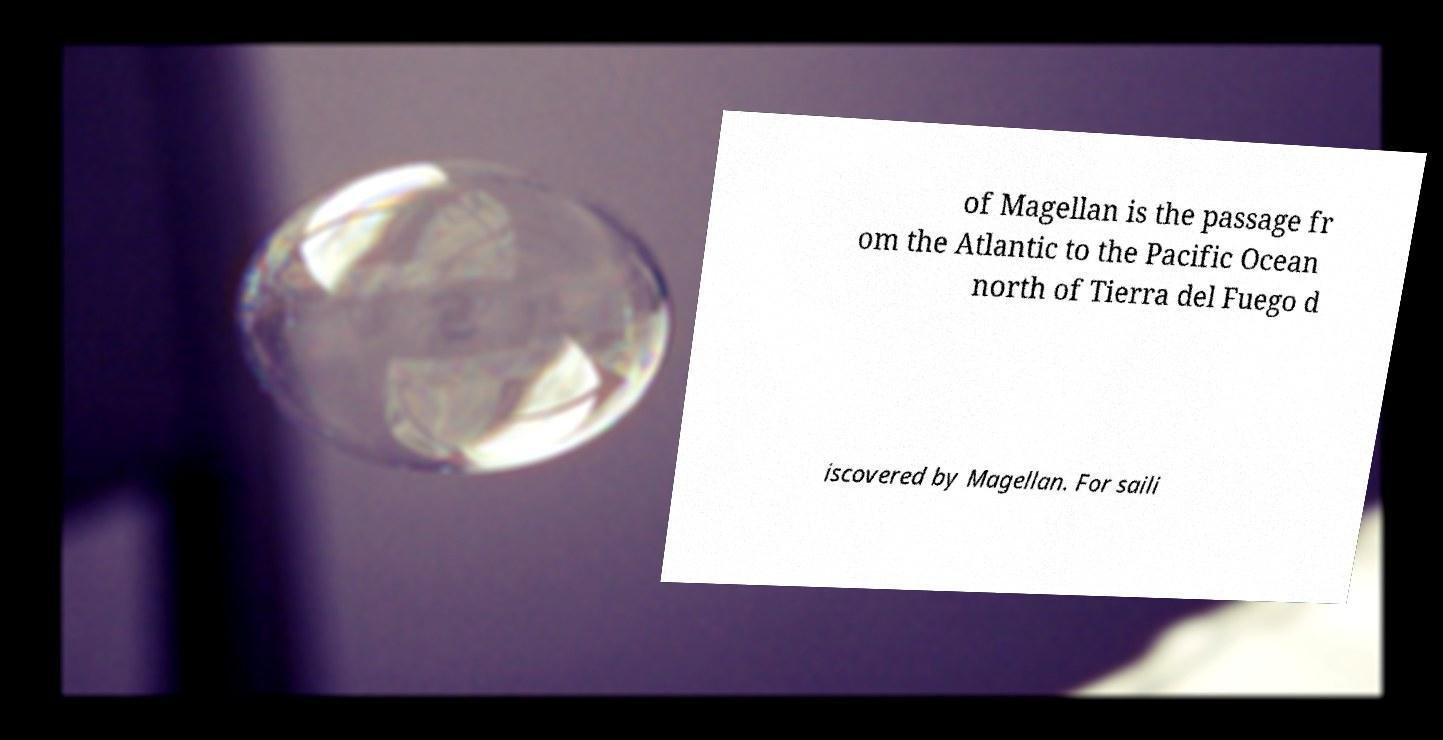Could you extract and type out the text from this image? of Magellan is the passage fr om the Atlantic to the Pacific Ocean north of Tierra del Fuego d iscovered by Magellan. For saili 